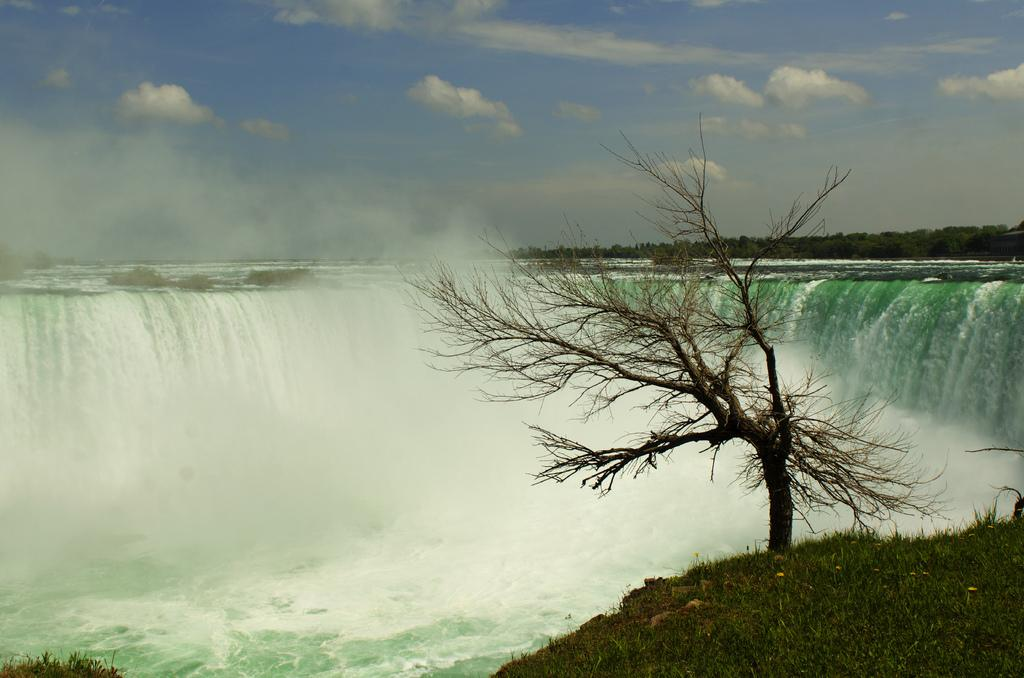What natural feature is the main subject of the image? There is a waterfall in the image. What type of vegetation can be seen in the image? There are trees and grass in the image. What is visible in the background of the image? The sky is visible in the background of the image. What can be observed in the sky? Clouds are present in the sky. What type of joke is being told by the tree in the image? There is no joke being told by a tree in the image, as trees do not have the ability to tell jokes. 